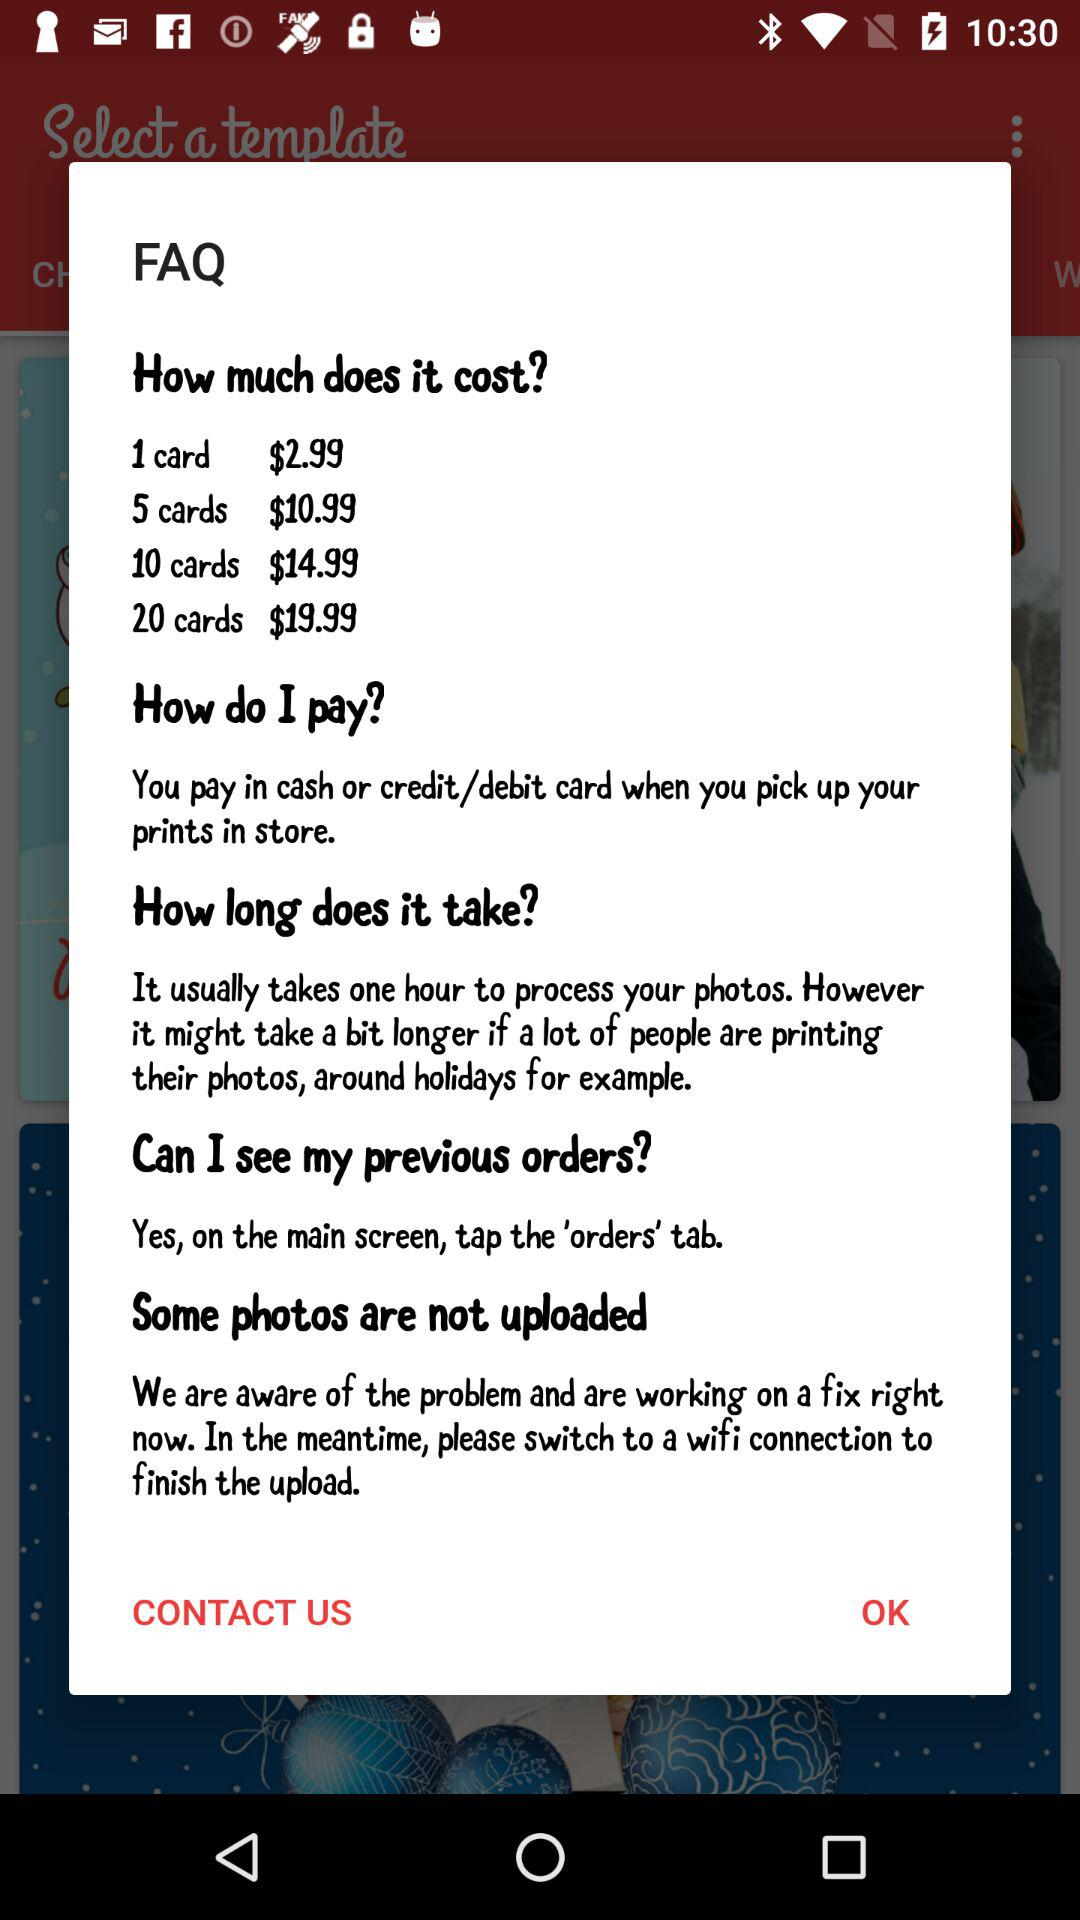How many different price points are there for printing cards?
Answer the question using a single word or phrase. 4 